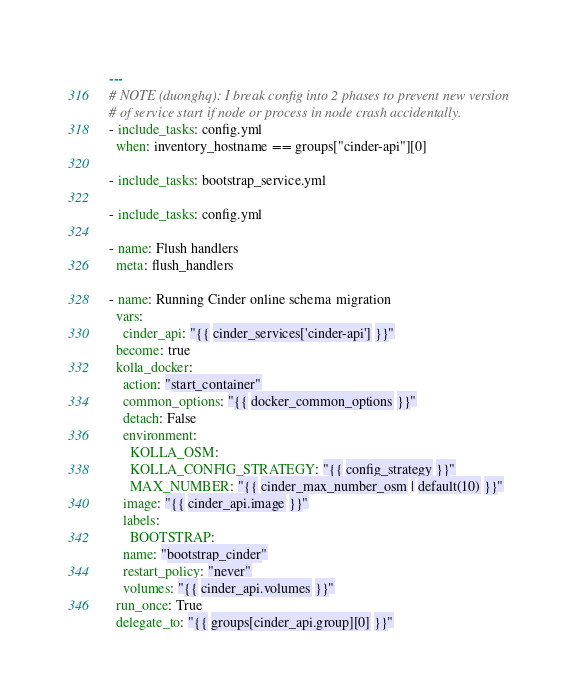Convert code to text. <code><loc_0><loc_0><loc_500><loc_500><_YAML_>---
# NOTE (duonghq): I break config into 2 phases to prevent new version
# of service start if node or process in node crash accidentally.
- include_tasks: config.yml
  when: inventory_hostname == groups["cinder-api"][0]

- include_tasks: bootstrap_service.yml

- include_tasks: config.yml

- name: Flush handlers
  meta: flush_handlers

- name: Running Cinder online schema migration
  vars:
    cinder_api: "{{ cinder_services['cinder-api'] }}"
  become: true
  kolla_docker:
    action: "start_container"
    common_options: "{{ docker_common_options }}"
    detach: False
    environment:
      KOLLA_OSM:
      KOLLA_CONFIG_STRATEGY: "{{ config_strategy }}"
      MAX_NUMBER: "{{ cinder_max_number_osm | default(10) }}"
    image: "{{ cinder_api.image }}"
    labels:
      BOOTSTRAP:
    name: "bootstrap_cinder"
    restart_policy: "never"
    volumes: "{{ cinder_api.volumes }}"
  run_once: True
  delegate_to: "{{ groups[cinder_api.group][0] }}"
</code> 